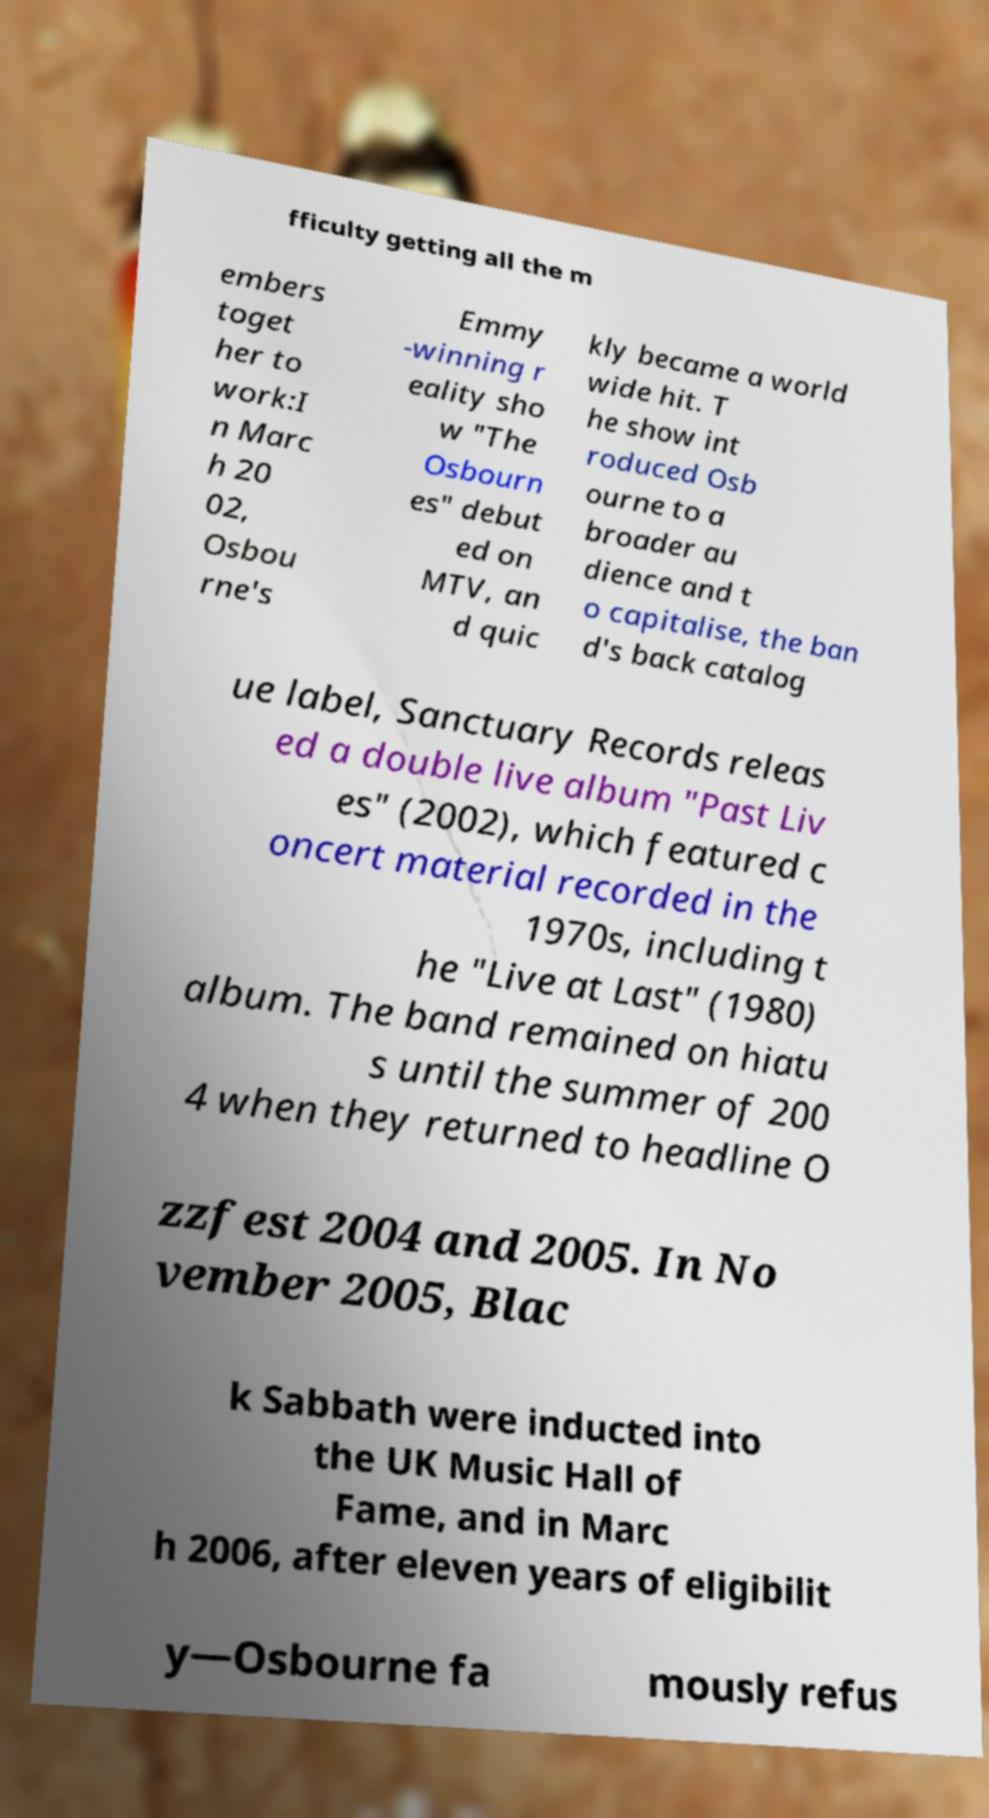Please identify and transcribe the text found in this image. fficulty getting all the m embers toget her to work:I n Marc h 20 02, Osbou rne's Emmy -winning r eality sho w "The Osbourn es" debut ed on MTV, an d quic kly became a world wide hit. T he show int roduced Osb ourne to a broader au dience and t o capitalise, the ban d's back catalog ue label, Sanctuary Records releas ed a double live album "Past Liv es" (2002), which featured c oncert material recorded in the 1970s, including t he "Live at Last" (1980) album. The band remained on hiatu s until the summer of 200 4 when they returned to headline O zzfest 2004 and 2005. In No vember 2005, Blac k Sabbath were inducted into the UK Music Hall of Fame, and in Marc h 2006, after eleven years of eligibilit y—Osbourne fa mously refus 